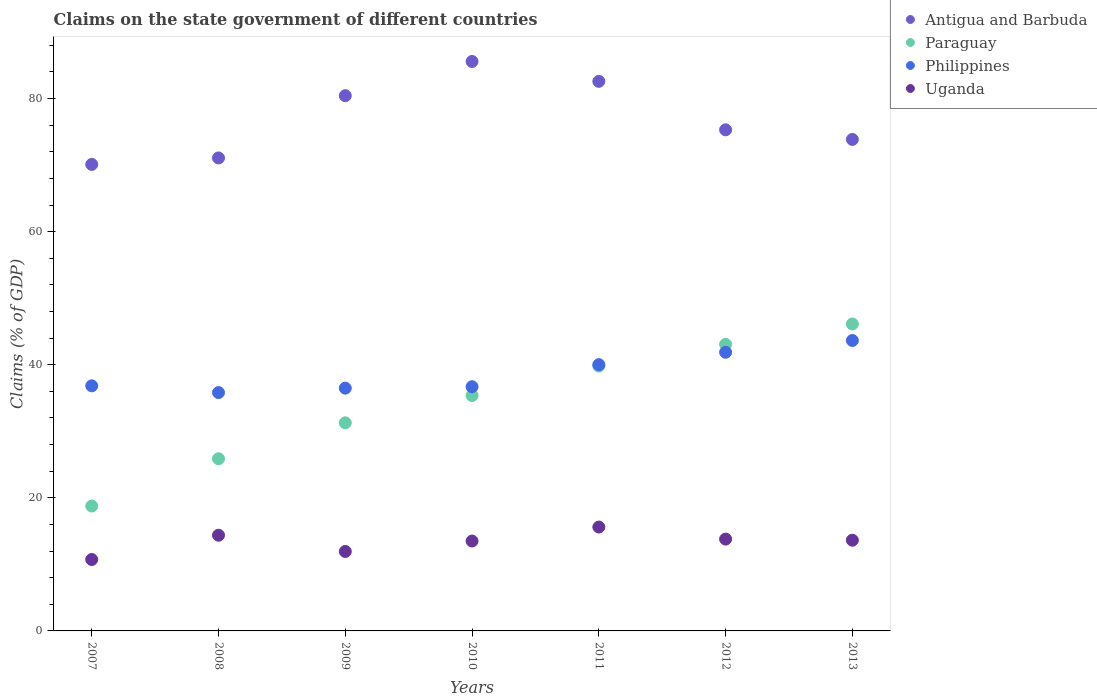What is the percentage of GDP claimed on the state government in Uganda in 2013?
Ensure brevity in your answer.  13.63. Across all years, what is the maximum percentage of GDP claimed on the state government in Uganda?
Make the answer very short. 15.61. Across all years, what is the minimum percentage of GDP claimed on the state government in Antigua and Barbuda?
Provide a succinct answer. 70.11. What is the total percentage of GDP claimed on the state government in Paraguay in the graph?
Make the answer very short. 240.28. What is the difference between the percentage of GDP claimed on the state government in Uganda in 2010 and that in 2013?
Keep it short and to the point. -0.12. What is the difference between the percentage of GDP claimed on the state government in Philippines in 2011 and the percentage of GDP claimed on the state government in Antigua and Barbuda in 2009?
Offer a very short reply. -40.42. What is the average percentage of GDP claimed on the state government in Philippines per year?
Make the answer very short. 38.77. In the year 2011, what is the difference between the percentage of GDP claimed on the state government in Antigua and Barbuda and percentage of GDP claimed on the state government in Philippines?
Your answer should be compact. 42.58. In how many years, is the percentage of GDP claimed on the state government in Uganda greater than 80 %?
Provide a short and direct response. 0. What is the ratio of the percentage of GDP claimed on the state government in Paraguay in 2007 to that in 2009?
Make the answer very short. 0.6. Is the percentage of GDP claimed on the state government in Paraguay in 2007 less than that in 2008?
Provide a succinct answer. Yes. What is the difference between the highest and the second highest percentage of GDP claimed on the state government in Antigua and Barbuda?
Keep it short and to the point. 2.99. What is the difference between the highest and the lowest percentage of GDP claimed on the state government in Uganda?
Offer a very short reply. 4.88. In how many years, is the percentage of GDP claimed on the state government in Philippines greater than the average percentage of GDP claimed on the state government in Philippines taken over all years?
Your response must be concise. 3. Is the sum of the percentage of GDP claimed on the state government in Paraguay in 2010 and 2012 greater than the maximum percentage of GDP claimed on the state government in Uganda across all years?
Ensure brevity in your answer.  Yes. Is it the case that in every year, the sum of the percentage of GDP claimed on the state government in Paraguay and percentage of GDP claimed on the state government in Philippines  is greater than the sum of percentage of GDP claimed on the state government in Antigua and Barbuda and percentage of GDP claimed on the state government in Uganda?
Your answer should be compact. No. Is it the case that in every year, the sum of the percentage of GDP claimed on the state government in Antigua and Barbuda and percentage of GDP claimed on the state government in Paraguay  is greater than the percentage of GDP claimed on the state government in Philippines?
Offer a very short reply. Yes. Does the percentage of GDP claimed on the state government in Paraguay monotonically increase over the years?
Offer a terse response. Yes. Is the percentage of GDP claimed on the state government in Uganda strictly less than the percentage of GDP claimed on the state government in Philippines over the years?
Your answer should be compact. Yes. How many dotlines are there?
Your answer should be compact. 4. How many years are there in the graph?
Provide a short and direct response. 7. What is the difference between two consecutive major ticks on the Y-axis?
Your response must be concise. 20. Are the values on the major ticks of Y-axis written in scientific E-notation?
Ensure brevity in your answer.  No. Does the graph contain grids?
Make the answer very short. No. Where does the legend appear in the graph?
Provide a short and direct response. Top right. How many legend labels are there?
Offer a terse response. 4. What is the title of the graph?
Keep it short and to the point. Claims on the state government of different countries. Does "Guatemala" appear as one of the legend labels in the graph?
Keep it short and to the point. No. What is the label or title of the Y-axis?
Make the answer very short. Claims (% of GDP). What is the Claims (% of GDP) in Antigua and Barbuda in 2007?
Your answer should be compact. 70.11. What is the Claims (% of GDP) in Paraguay in 2007?
Your answer should be very brief. 18.77. What is the Claims (% of GDP) of Philippines in 2007?
Provide a succinct answer. 36.83. What is the Claims (% of GDP) of Uganda in 2007?
Your response must be concise. 10.73. What is the Claims (% of GDP) of Antigua and Barbuda in 2008?
Provide a short and direct response. 71.08. What is the Claims (% of GDP) of Paraguay in 2008?
Offer a very short reply. 25.87. What is the Claims (% of GDP) of Philippines in 2008?
Give a very brief answer. 35.82. What is the Claims (% of GDP) of Uganda in 2008?
Provide a short and direct response. 14.38. What is the Claims (% of GDP) in Antigua and Barbuda in 2009?
Offer a terse response. 80.43. What is the Claims (% of GDP) of Paraguay in 2009?
Your response must be concise. 31.28. What is the Claims (% of GDP) of Philippines in 2009?
Your answer should be very brief. 36.48. What is the Claims (% of GDP) in Uganda in 2009?
Ensure brevity in your answer.  11.94. What is the Claims (% of GDP) of Antigua and Barbuda in 2010?
Provide a short and direct response. 85.58. What is the Claims (% of GDP) in Paraguay in 2010?
Your answer should be compact. 35.37. What is the Claims (% of GDP) in Philippines in 2010?
Provide a succinct answer. 36.7. What is the Claims (% of GDP) in Uganda in 2010?
Provide a succinct answer. 13.51. What is the Claims (% of GDP) in Antigua and Barbuda in 2011?
Your answer should be compact. 82.59. What is the Claims (% of GDP) of Paraguay in 2011?
Make the answer very short. 39.8. What is the Claims (% of GDP) of Philippines in 2011?
Offer a terse response. 40.02. What is the Claims (% of GDP) of Uganda in 2011?
Keep it short and to the point. 15.61. What is the Claims (% of GDP) of Antigua and Barbuda in 2012?
Give a very brief answer. 75.3. What is the Claims (% of GDP) of Paraguay in 2012?
Offer a very short reply. 43.07. What is the Claims (% of GDP) of Philippines in 2012?
Ensure brevity in your answer.  41.88. What is the Claims (% of GDP) in Uganda in 2012?
Offer a very short reply. 13.8. What is the Claims (% of GDP) of Antigua and Barbuda in 2013?
Keep it short and to the point. 73.86. What is the Claims (% of GDP) of Paraguay in 2013?
Keep it short and to the point. 46.13. What is the Claims (% of GDP) of Philippines in 2013?
Your answer should be very brief. 43.65. What is the Claims (% of GDP) in Uganda in 2013?
Make the answer very short. 13.63. Across all years, what is the maximum Claims (% of GDP) in Antigua and Barbuda?
Offer a terse response. 85.58. Across all years, what is the maximum Claims (% of GDP) of Paraguay?
Ensure brevity in your answer.  46.13. Across all years, what is the maximum Claims (% of GDP) in Philippines?
Keep it short and to the point. 43.65. Across all years, what is the maximum Claims (% of GDP) of Uganda?
Ensure brevity in your answer.  15.61. Across all years, what is the minimum Claims (% of GDP) of Antigua and Barbuda?
Give a very brief answer. 70.11. Across all years, what is the minimum Claims (% of GDP) of Paraguay?
Your answer should be very brief. 18.77. Across all years, what is the minimum Claims (% of GDP) of Philippines?
Offer a terse response. 35.82. Across all years, what is the minimum Claims (% of GDP) in Uganda?
Give a very brief answer. 10.73. What is the total Claims (% of GDP) in Antigua and Barbuda in the graph?
Ensure brevity in your answer.  538.95. What is the total Claims (% of GDP) of Paraguay in the graph?
Provide a short and direct response. 240.28. What is the total Claims (% of GDP) in Philippines in the graph?
Your answer should be very brief. 271.37. What is the total Claims (% of GDP) of Uganda in the graph?
Make the answer very short. 93.6. What is the difference between the Claims (% of GDP) of Antigua and Barbuda in 2007 and that in 2008?
Your response must be concise. -0.97. What is the difference between the Claims (% of GDP) of Paraguay in 2007 and that in 2008?
Make the answer very short. -7.1. What is the difference between the Claims (% of GDP) of Philippines in 2007 and that in 2008?
Provide a short and direct response. 1.01. What is the difference between the Claims (% of GDP) of Uganda in 2007 and that in 2008?
Your answer should be compact. -3.65. What is the difference between the Claims (% of GDP) of Antigua and Barbuda in 2007 and that in 2009?
Offer a very short reply. -10.33. What is the difference between the Claims (% of GDP) in Paraguay in 2007 and that in 2009?
Keep it short and to the point. -12.51. What is the difference between the Claims (% of GDP) of Philippines in 2007 and that in 2009?
Ensure brevity in your answer.  0.35. What is the difference between the Claims (% of GDP) in Uganda in 2007 and that in 2009?
Give a very brief answer. -1.21. What is the difference between the Claims (% of GDP) of Antigua and Barbuda in 2007 and that in 2010?
Ensure brevity in your answer.  -15.47. What is the difference between the Claims (% of GDP) in Paraguay in 2007 and that in 2010?
Offer a very short reply. -16.61. What is the difference between the Claims (% of GDP) of Philippines in 2007 and that in 2010?
Your answer should be very brief. 0.13. What is the difference between the Claims (% of GDP) of Uganda in 2007 and that in 2010?
Offer a terse response. -2.78. What is the difference between the Claims (% of GDP) in Antigua and Barbuda in 2007 and that in 2011?
Your answer should be very brief. -12.48. What is the difference between the Claims (% of GDP) in Paraguay in 2007 and that in 2011?
Offer a very short reply. -21.03. What is the difference between the Claims (% of GDP) in Philippines in 2007 and that in 2011?
Your response must be concise. -3.18. What is the difference between the Claims (% of GDP) in Uganda in 2007 and that in 2011?
Offer a terse response. -4.88. What is the difference between the Claims (% of GDP) in Antigua and Barbuda in 2007 and that in 2012?
Your answer should be compact. -5.2. What is the difference between the Claims (% of GDP) in Paraguay in 2007 and that in 2012?
Your answer should be very brief. -24.3. What is the difference between the Claims (% of GDP) of Philippines in 2007 and that in 2012?
Provide a short and direct response. -5.04. What is the difference between the Claims (% of GDP) of Uganda in 2007 and that in 2012?
Your answer should be compact. -3.07. What is the difference between the Claims (% of GDP) in Antigua and Barbuda in 2007 and that in 2013?
Provide a short and direct response. -3.75. What is the difference between the Claims (% of GDP) in Paraguay in 2007 and that in 2013?
Your response must be concise. -27.36. What is the difference between the Claims (% of GDP) in Philippines in 2007 and that in 2013?
Your answer should be very brief. -6.81. What is the difference between the Claims (% of GDP) in Uganda in 2007 and that in 2013?
Your answer should be very brief. -2.9. What is the difference between the Claims (% of GDP) in Antigua and Barbuda in 2008 and that in 2009?
Provide a short and direct response. -9.35. What is the difference between the Claims (% of GDP) in Paraguay in 2008 and that in 2009?
Offer a terse response. -5.4. What is the difference between the Claims (% of GDP) in Philippines in 2008 and that in 2009?
Make the answer very short. -0.66. What is the difference between the Claims (% of GDP) of Uganda in 2008 and that in 2009?
Your answer should be very brief. 2.44. What is the difference between the Claims (% of GDP) of Antigua and Barbuda in 2008 and that in 2010?
Offer a very short reply. -14.5. What is the difference between the Claims (% of GDP) of Paraguay in 2008 and that in 2010?
Keep it short and to the point. -9.5. What is the difference between the Claims (% of GDP) in Philippines in 2008 and that in 2010?
Provide a succinct answer. -0.88. What is the difference between the Claims (% of GDP) in Uganda in 2008 and that in 2010?
Provide a succinct answer. 0.87. What is the difference between the Claims (% of GDP) in Antigua and Barbuda in 2008 and that in 2011?
Ensure brevity in your answer.  -11.51. What is the difference between the Claims (% of GDP) of Paraguay in 2008 and that in 2011?
Offer a very short reply. -13.93. What is the difference between the Claims (% of GDP) of Philippines in 2008 and that in 2011?
Make the answer very short. -4.2. What is the difference between the Claims (% of GDP) of Uganda in 2008 and that in 2011?
Your response must be concise. -1.23. What is the difference between the Claims (% of GDP) in Antigua and Barbuda in 2008 and that in 2012?
Give a very brief answer. -4.23. What is the difference between the Claims (% of GDP) of Paraguay in 2008 and that in 2012?
Keep it short and to the point. -17.2. What is the difference between the Claims (% of GDP) of Philippines in 2008 and that in 2012?
Make the answer very short. -6.06. What is the difference between the Claims (% of GDP) of Uganda in 2008 and that in 2012?
Offer a very short reply. 0.58. What is the difference between the Claims (% of GDP) of Antigua and Barbuda in 2008 and that in 2013?
Ensure brevity in your answer.  -2.78. What is the difference between the Claims (% of GDP) of Paraguay in 2008 and that in 2013?
Keep it short and to the point. -20.26. What is the difference between the Claims (% of GDP) of Philippines in 2008 and that in 2013?
Your answer should be very brief. -7.83. What is the difference between the Claims (% of GDP) of Uganda in 2008 and that in 2013?
Keep it short and to the point. 0.75. What is the difference between the Claims (% of GDP) in Antigua and Barbuda in 2009 and that in 2010?
Your answer should be compact. -5.14. What is the difference between the Claims (% of GDP) in Paraguay in 2009 and that in 2010?
Give a very brief answer. -4.1. What is the difference between the Claims (% of GDP) in Philippines in 2009 and that in 2010?
Offer a very short reply. -0.22. What is the difference between the Claims (% of GDP) in Uganda in 2009 and that in 2010?
Provide a short and direct response. -1.57. What is the difference between the Claims (% of GDP) in Antigua and Barbuda in 2009 and that in 2011?
Make the answer very short. -2.16. What is the difference between the Claims (% of GDP) in Paraguay in 2009 and that in 2011?
Your answer should be very brief. -8.52. What is the difference between the Claims (% of GDP) in Philippines in 2009 and that in 2011?
Give a very brief answer. -3.53. What is the difference between the Claims (% of GDP) of Uganda in 2009 and that in 2011?
Give a very brief answer. -3.67. What is the difference between the Claims (% of GDP) in Antigua and Barbuda in 2009 and that in 2012?
Your response must be concise. 5.13. What is the difference between the Claims (% of GDP) in Paraguay in 2009 and that in 2012?
Provide a short and direct response. -11.79. What is the difference between the Claims (% of GDP) in Philippines in 2009 and that in 2012?
Give a very brief answer. -5.39. What is the difference between the Claims (% of GDP) in Uganda in 2009 and that in 2012?
Provide a succinct answer. -1.86. What is the difference between the Claims (% of GDP) of Antigua and Barbuda in 2009 and that in 2013?
Provide a succinct answer. 6.57. What is the difference between the Claims (% of GDP) of Paraguay in 2009 and that in 2013?
Give a very brief answer. -14.85. What is the difference between the Claims (% of GDP) in Philippines in 2009 and that in 2013?
Provide a succinct answer. -7.16. What is the difference between the Claims (% of GDP) of Uganda in 2009 and that in 2013?
Your answer should be very brief. -1.69. What is the difference between the Claims (% of GDP) in Antigua and Barbuda in 2010 and that in 2011?
Offer a very short reply. 2.99. What is the difference between the Claims (% of GDP) in Paraguay in 2010 and that in 2011?
Keep it short and to the point. -4.42. What is the difference between the Claims (% of GDP) of Philippines in 2010 and that in 2011?
Ensure brevity in your answer.  -3.32. What is the difference between the Claims (% of GDP) of Uganda in 2010 and that in 2011?
Keep it short and to the point. -2.1. What is the difference between the Claims (% of GDP) of Antigua and Barbuda in 2010 and that in 2012?
Keep it short and to the point. 10.27. What is the difference between the Claims (% of GDP) of Paraguay in 2010 and that in 2012?
Give a very brief answer. -7.69. What is the difference between the Claims (% of GDP) of Philippines in 2010 and that in 2012?
Provide a short and direct response. -5.18. What is the difference between the Claims (% of GDP) in Uganda in 2010 and that in 2012?
Keep it short and to the point. -0.29. What is the difference between the Claims (% of GDP) of Antigua and Barbuda in 2010 and that in 2013?
Provide a short and direct response. 11.71. What is the difference between the Claims (% of GDP) in Paraguay in 2010 and that in 2013?
Give a very brief answer. -10.75. What is the difference between the Claims (% of GDP) in Philippines in 2010 and that in 2013?
Your answer should be compact. -6.95. What is the difference between the Claims (% of GDP) of Uganda in 2010 and that in 2013?
Give a very brief answer. -0.12. What is the difference between the Claims (% of GDP) of Antigua and Barbuda in 2011 and that in 2012?
Your answer should be very brief. 7.29. What is the difference between the Claims (% of GDP) in Paraguay in 2011 and that in 2012?
Your answer should be compact. -3.27. What is the difference between the Claims (% of GDP) in Philippines in 2011 and that in 2012?
Ensure brevity in your answer.  -1.86. What is the difference between the Claims (% of GDP) in Uganda in 2011 and that in 2012?
Keep it short and to the point. 1.81. What is the difference between the Claims (% of GDP) of Antigua and Barbuda in 2011 and that in 2013?
Make the answer very short. 8.73. What is the difference between the Claims (% of GDP) of Paraguay in 2011 and that in 2013?
Make the answer very short. -6.33. What is the difference between the Claims (% of GDP) in Philippines in 2011 and that in 2013?
Offer a very short reply. -3.63. What is the difference between the Claims (% of GDP) in Uganda in 2011 and that in 2013?
Offer a very short reply. 1.98. What is the difference between the Claims (% of GDP) in Antigua and Barbuda in 2012 and that in 2013?
Ensure brevity in your answer.  1.44. What is the difference between the Claims (% of GDP) in Paraguay in 2012 and that in 2013?
Your answer should be compact. -3.06. What is the difference between the Claims (% of GDP) of Philippines in 2012 and that in 2013?
Offer a terse response. -1.77. What is the difference between the Claims (% of GDP) in Uganda in 2012 and that in 2013?
Your answer should be very brief. 0.17. What is the difference between the Claims (% of GDP) in Antigua and Barbuda in 2007 and the Claims (% of GDP) in Paraguay in 2008?
Offer a terse response. 44.24. What is the difference between the Claims (% of GDP) of Antigua and Barbuda in 2007 and the Claims (% of GDP) of Philippines in 2008?
Provide a short and direct response. 34.29. What is the difference between the Claims (% of GDP) in Antigua and Barbuda in 2007 and the Claims (% of GDP) in Uganda in 2008?
Make the answer very short. 55.73. What is the difference between the Claims (% of GDP) in Paraguay in 2007 and the Claims (% of GDP) in Philippines in 2008?
Give a very brief answer. -17.05. What is the difference between the Claims (% of GDP) in Paraguay in 2007 and the Claims (% of GDP) in Uganda in 2008?
Offer a terse response. 4.39. What is the difference between the Claims (% of GDP) in Philippines in 2007 and the Claims (% of GDP) in Uganda in 2008?
Provide a succinct answer. 22.45. What is the difference between the Claims (% of GDP) in Antigua and Barbuda in 2007 and the Claims (% of GDP) in Paraguay in 2009?
Offer a very short reply. 38.83. What is the difference between the Claims (% of GDP) in Antigua and Barbuda in 2007 and the Claims (% of GDP) in Philippines in 2009?
Offer a very short reply. 33.62. What is the difference between the Claims (% of GDP) of Antigua and Barbuda in 2007 and the Claims (% of GDP) of Uganda in 2009?
Ensure brevity in your answer.  58.17. What is the difference between the Claims (% of GDP) in Paraguay in 2007 and the Claims (% of GDP) in Philippines in 2009?
Offer a terse response. -17.72. What is the difference between the Claims (% of GDP) of Paraguay in 2007 and the Claims (% of GDP) of Uganda in 2009?
Offer a very short reply. 6.83. What is the difference between the Claims (% of GDP) of Philippines in 2007 and the Claims (% of GDP) of Uganda in 2009?
Offer a very short reply. 24.89. What is the difference between the Claims (% of GDP) of Antigua and Barbuda in 2007 and the Claims (% of GDP) of Paraguay in 2010?
Offer a very short reply. 34.73. What is the difference between the Claims (% of GDP) of Antigua and Barbuda in 2007 and the Claims (% of GDP) of Philippines in 2010?
Your answer should be very brief. 33.41. What is the difference between the Claims (% of GDP) in Antigua and Barbuda in 2007 and the Claims (% of GDP) in Uganda in 2010?
Keep it short and to the point. 56.6. What is the difference between the Claims (% of GDP) of Paraguay in 2007 and the Claims (% of GDP) of Philippines in 2010?
Offer a very short reply. -17.93. What is the difference between the Claims (% of GDP) of Paraguay in 2007 and the Claims (% of GDP) of Uganda in 2010?
Make the answer very short. 5.26. What is the difference between the Claims (% of GDP) of Philippines in 2007 and the Claims (% of GDP) of Uganda in 2010?
Provide a succinct answer. 23.32. What is the difference between the Claims (% of GDP) of Antigua and Barbuda in 2007 and the Claims (% of GDP) of Paraguay in 2011?
Offer a terse response. 30.31. What is the difference between the Claims (% of GDP) in Antigua and Barbuda in 2007 and the Claims (% of GDP) in Philippines in 2011?
Your response must be concise. 30.09. What is the difference between the Claims (% of GDP) in Antigua and Barbuda in 2007 and the Claims (% of GDP) in Uganda in 2011?
Keep it short and to the point. 54.5. What is the difference between the Claims (% of GDP) of Paraguay in 2007 and the Claims (% of GDP) of Philippines in 2011?
Give a very brief answer. -21.25. What is the difference between the Claims (% of GDP) of Paraguay in 2007 and the Claims (% of GDP) of Uganda in 2011?
Make the answer very short. 3.16. What is the difference between the Claims (% of GDP) in Philippines in 2007 and the Claims (% of GDP) in Uganda in 2011?
Offer a terse response. 21.22. What is the difference between the Claims (% of GDP) of Antigua and Barbuda in 2007 and the Claims (% of GDP) of Paraguay in 2012?
Your answer should be compact. 27.04. What is the difference between the Claims (% of GDP) in Antigua and Barbuda in 2007 and the Claims (% of GDP) in Philippines in 2012?
Provide a short and direct response. 28.23. What is the difference between the Claims (% of GDP) of Antigua and Barbuda in 2007 and the Claims (% of GDP) of Uganda in 2012?
Your response must be concise. 56.31. What is the difference between the Claims (% of GDP) of Paraguay in 2007 and the Claims (% of GDP) of Philippines in 2012?
Provide a short and direct response. -23.11. What is the difference between the Claims (% of GDP) in Paraguay in 2007 and the Claims (% of GDP) in Uganda in 2012?
Provide a short and direct response. 4.97. What is the difference between the Claims (% of GDP) of Philippines in 2007 and the Claims (% of GDP) of Uganda in 2012?
Your response must be concise. 23.03. What is the difference between the Claims (% of GDP) in Antigua and Barbuda in 2007 and the Claims (% of GDP) in Paraguay in 2013?
Your answer should be very brief. 23.98. What is the difference between the Claims (% of GDP) in Antigua and Barbuda in 2007 and the Claims (% of GDP) in Philippines in 2013?
Provide a short and direct response. 26.46. What is the difference between the Claims (% of GDP) in Antigua and Barbuda in 2007 and the Claims (% of GDP) in Uganda in 2013?
Make the answer very short. 56.47. What is the difference between the Claims (% of GDP) in Paraguay in 2007 and the Claims (% of GDP) in Philippines in 2013?
Make the answer very short. -24.88. What is the difference between the Claims (% of GDP) in Paraguay in 2007 and the Claims (% of GDP) in Uganda in 2013?
Keep it short and to the point. 5.14. What is the difference between the Claims (% of GDP) in Philippines in 2007 and the Claims (% of GDP) in Uganda in 2013?
Your answer should be very brief. 23.2. What is the difference between the Claims (% of GDP) in Antigua and Barbuda in 2008 and the Claims (% of GDP) in Paraguay in 2009?
Offer a terse response. 39.8. What is the difference between the Claims (% of GDP) in Antigua and Barbuda in 2008 and the Claims (% of GDP) in Philippines in 2009?
Provide a short and direct response. 34.6. What is the difference between the Claims (% of GDP) of Antigua and Barbuda in 2008 and the Claims (% of GDP) of Uganda in 2009?
Your answer should be very brief. 59.14. What is the difference between the Claims (% of GDP) in Paraguay in 2008 and the Claims (% of GDP) in Philippines in 2009?
Your response must be concise. -10.61. What is the difference between the Claims (% of GDP) in Paraguay in 2008 and the Claims (% of GDP) in Uganda in 2009?
Ensure brevity in your answer.  13.93. What is the difference between the Claims (% of GDP) of Philippines in 2008 and the Claims (% of GDP) of Uganda in 2009?
Your response must be concise. 23.88. What is the difference between the Claims (% of GDP) in Antigua and Barbuda in 2008 and the Claims (% of GDP) in Paraguay in 2010?
Give a very brief answer. 35.7. What is the difference between the Claims (% of GDP) in Antigua and Barbuda in 2008 and the Claims (% of GDP) in Philippines in 2010?
Your answer should be compact. 34.38. What is the difference between the Claims (% of GDP) of Antigua and Barbuda in 2008 and the Claims (% of GDP) of Uganda in 2010?
Offer a terse response. 57.57. What is the difference between the Claims (% of GDP) in Paraguay in 2008 and the Claims (% of GDP) in Philippines in 2010?
Your answer should be compact. -10.83. What is the difference between the Claims (% of GDP) of Paraguay in 2008 and the Claims (% of GDP) of Uganda in 2010?
Your answer should be very brief. 12.36. What is the difference between the Claims (% of GDP) in Philippines in 2008 and the Claims (% of GDP) in Uganda in 2010?
Provide a short and direct response. 22.31. What is the difference between the Claims (% of GDP) in Antigua and Barbuda in 2008 and the Claims (% of GDP) in Paraguay in 2011?
Give a very brief answer. 31.28. What is the difference between the Claims (% of GDP) in Antigua and Barbuda in 2008 and the Claims (% of GDP) in Philippines in 2011?
Give a very brief answer. 31.06. What is the difference between the Claims (% of GDP) in Antigua and Barbuda in 2008 and the Claims (% of GDP) in Uganda in 2011?
Make the answer very short. 55.47. What is the difference between the Claims (% of GDP) of Paraguay in 2008 and the Claims (% of GDP) of Philippines in 2011?
Make the answer very short. -14.14. What is the difference between the Claims (% of GDP) of Paraguay in 2008 and the Claims (% of GDP) of Uganda in 2011?
Provide a short and direct response. 10.26. What is the difference between the Claims (% of GDP) of Philippines in 2008 and the Claims (% of GDP) of Uganda in 2011?
Keep it short and to the point. 20.21. What is the difference between the Claims (% of GDP) of Antigua and Barbuda in 2008 and the Claims (% of GDP) of Paraguay in 2012?
Your answer should be compact. 28.01. What is the difference between the Claims (% of GDP) of Antigua and Barbuda in 2008 and the Claims (% of GDP) of Philippines in 2012?
Ensure brevity in your answer.  29.2. What is the difference between the Claims (% of GDP) of Antigua and Barbuda in 2008 and the Claims (% of GDP) of Uganda in 2012?
Your answer should be very brief. 57.28. What is the difference between the Claims (% of GDP) of Paraguay in 2008 and the Claims (% of GDP) of Philippines in 2012?
Your response must be concise. -16. What is the difference between the Claims (% of GDP) in Paraguay in 2008 and the Claims (% of GDP) in Uganda in 2012?
Provide a short and direct response. 12.07. What is the difference between the Claims (% of GDP) in Philippines in 2008 and the Claims (% of GDP) in Uganda in 2012?
Make the answer very short. 22.02. What is the difference between the Claims (% of GDP) of Antigua and Barbuda in 2008 and the Claims (% of GDP) of Paraguay in 2013?
Your response must be concise. 24.95. What is the difference between the Claims (% of GDP) in Antigua and Barbuda in 2008 and the Claims (% of GDP) in Philippines in 2013?
Provide a succinct answer. 27.43. What is the difference between the Claims (% of GDP) in Antigua and Barbuda in 2008 and the Claims (% of GDP) in Uganda in 2013?
Your response must be concise. 57.45. What is the difference between the Claims (% of GDP) in Paraguay in 2008 and the Claims (% of GDP) in Philippines in 2013?
Provide a succinct answer. -17.77. What is the difference between the Claims (% of GDP) of Paraguay in 2008 and the Claims (% of GDP) of Uganda in 2013?
Keep it short and to the point. 12.24. What is the difference between the Claims (% of GDP) in Philippines in 2008 and the Claims (% of GDP) in Uganda in 2013?
Your answer should be compact. 22.19. What is the difference between the Claims (% of GDP) in Antigua and Barbuda in 2009 and the Claims (% of GDP) in Paraguay in 2010?
Your answer should be compact. 45.06. What is the difference between the Claims (% of GDP) of Antigua and Barbuda in 2009 and the Claims (% of GDP) of Philippines in 2010?
Provide a succinct answer. 43.74. What is the difference between the Claims (% of GDP) in Antigua and Barbuda in 2009 and the Claims (% of GDP) in Uganda in 2010?
Your answer should be compact. 66.92. What is the difference between the Claims (% of GDP) of Paraguay in 2009 and the Claims (% of GDP) of Philippines in 2010?
Your answer should be compact. -5.42. What is the difference between the Claims (% of GDP) in Paraguay in 2009 and the Claims (% of GDP) in Uganda in 2010?
Your answer should be compact. 17.77. What is the difference between the Claims (% of GDP) of Philippines in 2009 and the Claims (% of GDP) of Uganda in 2010?
Ensure brevity in your answer.  22.97. What is the difference between the Claims (% of GDP) of Antigua and Barbuda in 2009 and the Claims (% of GDP) of Paraguay in 2011?
Make the answer very short. 40.64. What is the difference between the Claims (% of GDP) in Antigua and Barbuda in 2009 and the Claims (% of GDP) in Philippines in 2011?
Offer a very short reply. 40.42. What is the difference between the Claims (% of GDP) of Antigua and Barbuda in 2009 and the Claims (% of GDP) of Uganda in 2011?
Make the answer very short. 64.82. What is the difference between the Claims (% of GDP) of Paraguay in 2009 and the Claims (% of GDP) of Philippines in 2011?
Give a very brief answer. -8.74. What is the difference between the Claims (% of GDP) in Paraguay in 2009 and the Claims (% of GDP) in Uganda in 2011?
Make the answer very short. 15.66. What is the difference between the Claims (% of GDP) of Philippines in 2009 and the Claims (% of GDP) of Uganda in 2011?
Provide a short and direct response. 20.87. What is the difference between the Claims (% of GDP) in Antigua and Barbuda in 2009 and the Claims (% of GDP) in Paraguay in 2012?
Offer a terse response. 37.37. What is the difference between the Claims (% of GDP) of Antigua and Barbuda in 2009 and the Claims (% of GDP) of Philippines in 2012?
Your response must be concise. 38.56. What is the difference between the Claims (% of GDP) in Antigua and Barbuda in 2009 and the Claims (% of GDP) in Uganda in 2012?
Your response must be concise. 66.64. What is the difference between the Claims (% of GDP) of Paraguay in 2009 and the Claims (% of GDP) of Philippines in 2012?
Your answer should be compact. -10.6. What is the difference between the Claims (% of GDP) in Paraguay in 2009 and the Claims (% of GDP) in Uganda in 2012?
Give a very brief answer. 17.48. What is the difference between the Claims (% of GDP) of Philippines in 2009 and the Claims (% of GDP) of Uganda in 2012?
Your answer should be very brief. 22.68. What is the difference between the Claims (% of GDP) of Antigua and Barbuda in 2009 and the Claims (% of GDP) of Paraguay in 2013?
Make the answer very short. 34.31. What is the difference between the Claims (% of GDP) in Antigua and Barbuda in 2009 and the Claims (% of GDP) in Philippines in 2013?
Provide a short and direct response. 36.79. What is the difference between the Claims (% of GDP) of Antigua and Barbuda in 2009 and the Claims (% of GDP) of Uganda in 2013?
Ensure brevity in your answer.  66.8. What is the difference between the Claims (% of GDP) of Paraguay in 2009 and the Claims (% of GDP) of Philippines in 2013?
Your answer should be very brief. -12.37. What is the difference between the Claims (% of GDP) of Paraguay in 2009 and the Claims (% of GDP) of Uganda in 2013?
Keep it short and to the point. 17.64. What is the difference between the Claims (% of GDP) in Philippines in 2009 and the Claims (% of GDP) in Uganda in 2013?
Offer a terse response. 22.85. What is the difference between the Claims (% of GDP) of Antigua and Barbuda in 2010 and the Claims (% of GDP) of Paraguay in 2011?
Keep it short and to the point. 45.78. What is the difference between the Claims (% of GDP) of Antigua and Barbuda in 2010 and the Claims (% of GDP) of Philippines in 2011?
Provide a succinct answer. 45.56. What is the difference between the Claims (% of GDP) of Antigua and Barbuda in 2010 and the Claims (% of GDP) of Uganda in 2011?
Provide a succinct answer. 69.97. What is the difference between the Claims (% of GDP) in Paraguay in 2010 and the Claims (% of GDP) in Philippines in 2011?
Keep it short and to the point. -4.64. What is the difference between the Claims (% of GDP) of Paraguay in 2010 and the Claims (% of GDP) of Uganda in 2011?
Your response must be concise. 19.76. What is the difference between the Claims (% of GDP) in Philippines in 2010 and the Claims (% of GDP) in Uganda in 2011?
Provide a short and direct response. 21.09. What is the difference between the Claims (% of GDP) in Antigua and Barbuda in 2010 and the Claims (% of GDP) in Paraguay in 2012?
Offer a very short reply. 42.51. What is the difference between the Claims (% of GDP) in Antigua and Barbuda in 2010 and the Claims (% of GDP) in Philippines in 2012?
Your response must be concise. 43.7. What is the difference between the Claims (% of GDP) in Antigua and Barbuda in 2010 and the Claims (% of GDP) in Uganda in 2012?
Ensure brevity in your answer.  71.78. What is the difference between the Claims (% of GDP) in Paraguay in 2010 and the Claims (% of GDP) in Philippines in 2012?
Give a very brief answer. -6.5. What is the difference between the Claims (% of GDP) of Paraguay in 2010 and the Claims (% of GDP) of Uganda in 2012?
Your answer should be very brief. 21.58. What is the difference between the Claims (% of GDP) of Philippines in 2010 and the Claims (% of GDP) of Uganda in 2012?
Your answer should be compact. 22.9. What is the difference between the Claims (% of GDP) in Antigua and Barbuda in 2010 and the Claims (% of GDP) in Paraguay in 2013?
Ensure brevity in your answer.  39.45. What is the difference between the Claims (% of GDP) in Antigua and Barbuda in 2010 and the Claims (% of GDP) in Philippines in 2013?
Offer a very short reply. 41.93. What is the difference between the Claims (% of GDP) in Antigua and Barbuda in 2010 and the Claims (% of GDP) in Uganda in 2013?
Ensure brevity in your answer.  71.94. What is the difference between the Claims (% of GDP) in Paraguay in 2010 and the Claims (% of GDP) in Philippines in 2013?
Offer a terse response. -8.27. What is the difference between the Claims (% of GDP) in Paraguay in 2010 and the Claims (% of GDP) in Uganda in 2013?
Ensure brevity in your answer.  21.74. What is the difference between the Claims (% of GDP) of Philippines in 2010 and the Claims (% of GDP) of Uganda in 2013?
Your response must be concise. 23.07. What is the difference between the Claims (% of GDP) of Antigua and Barbuda in 2011 and the Claims (% of GDP) of Paraguay in 2012?
Ensure brevity in your answer.  39.52. What is the difference between the Claims (% of GDP) of Antigua and Barbuda in 2011 and the Claims (% of GDP) of Philippines in 2012?
Offer a terse response. 40.72. What is the difference between the Claims (% of GDP) of Antigua and Barbuda in 2011 and the Claims (% of GDP) of Uganda in 2012?
Offer a terse response. 68.79. What is the difference between the Claims (% of GDP) of Paraguay in 2011 and the Claims (% of GDP) of Philippines in 2012?
Ensure brevity in your answer.  -2.08. What is the difference between the Claims (% of GDP) in Paraguay in 2011 and the Claims (% of GDP) in Uganda in 2012?
Ensure brevity in your answer.  26. What is the difference between the Claims (% of GDP) in Philippines in 2011 and the Claims (% of GDP) in Uganda in 2012?
Keep it short and to the point. 26.22. What is the difference between the Claims (% of GDP) of Antigua and Barbuda in 2011 and the Claims (% of GDP) of Paraguay in 2013?
Make the answer very short. 36.46. What is the difference between the Claims (% of GDP) of Antigua and Barbuda in 2011 and the Claims (% of GDP) of Philippines in 2013?
Your answer should be compact. 38.94. What is the difference between the Claims (% of GDP) of Antigua and Barbuda in 2011 and the Claims (% of GDP) of Uganda in 2013?
Ensure brevity in your answer.  68.96. What is the difference between the Claims (% of GDP) of Paraguay in 2011 and the Claims (% of GDP) of Philippines in 2013?
Give a very brief answer. -3.85. What is the difference between the Claims (% of GDP) in Paraguay in 2011 and the Claims (% of GDP) in Uganda in 2013?
Offer a very short reply. 26.16. What is the difference between the Claims (% of GDP) of Philippines in 2011 and the Claims (% of GDP) of Uganda in 2013?
Offer a terse response. 26.38. What is the difference between the Claims (% of GDP) in Antigua and Barbuda in 2012 and the Claims (% of GDP) in Paraguay in 2013?
Give a very brief answer. 29.18. What is the difference between the Claims (% of GDP) in Antigua and Barbuda in 2012 and the Claims (% of GDP) in Philippines in 2013?
Keep it short and to the point. 31.66. What is the difference between the Claims (% of GDP) of Antigua and Barbuda in 2012 and the Claims (% of GDP) of Uganda in 2013?
Provide a short and direct response. 61.67. What is the difference between the Claims (% of GDP) of Paraguay in 2012 and the Claims (% of GDP) of Philippines in 2013?
Provide a succinct answer. -0.58. What is the difference between the Claims (% of GDP) in Paraguay in 2012 and the Claims (% of GDP) in Uganda in 2013?
Your answer should be very brief. 29.44. What is the difference between the Claims (% of GDP) in Philippines in 2012 and the Claims (% of GDP) in Uganda in 2013?
Your response must be concise. 28.24. What is the average Claims (% of GDP) in Antigua and Barbuda per year?
Offer a terse response. 76.99. What is the average Claims (% of GDP) in Paraguay per year?
Offer a very short reply. 34.33. What is the average Claims (% of GDP) of Philippines per year?
Provide a short and direct response. 38.77. What is the average Claims (% of GDP) of Uganda per year?
Your answer should be compact. 13.37. In the year 2007, what is the difference between the Claims (% of GDP) of Antigua and Barbuda and Claims (% of GDP) of Paraguay?
Give a very brief answer. 51.34. In the year 2007, what is the difference between the Claims (% of GDP) of Antigua and Barbuda and Claims (% of GDP) of Philippines?
Your answer should be compact. 33.27. In the year 2007, what is the difference between the Claims (% of GDP) in Antigua and Barbuda and Claims (% of GDP) in Uganda?
Offer a very short reply. 59.38. In the year 2007, what is the difference between the Claims (% of GDP) of Paraguay and Claims (% of GDP) of Philippines?
Provide a short and direct response. -18.07. In the year 2007, what is the difference between the Claims (% of GDP) of Paraguay and Claims (% of GDP) of Uganda?
Your answer should be very brief. 8.04. In the year 2007, what is the difference between the Claims (% of GDP) in Philippines and Claims (% of GDP) in Uganda?
Provide a succinct answer. 26.1. In the year 2008, what is the difference between the Claims (% of GDP) in Antigua and Barbuda and Claims (% of GDP) in Paraguay?
Keep it short and to the point. 45.21. In the year 2008, what is the difference between the Claims (% of GDP) in Antigua and Barbuda and Claims (% of GDP) in Philippines?
Give a very brief answer. 35.26. In the year 2008, what is the difference between the Claims (% of GDP) of Antigua and Barbuda and Claims (% of GDP) of Uganda?
Your response must be concise. 56.7. In the year 2008, what is the difference between the Claims (% of GDP) of Paraguay and Claims (% of GDP) of Philippines?
Offer a terse response. -9.95. In the year 2008, what is the difference between the Claims (% of GDP) in Paraguay and Claims (% of GDP) in Uganda?
Your answer should be very brief. 11.49. In the year 2008, what is the difference between the Claims (% of GDP) of Philippines and Claims (% of GDP) of Uganda?
Your answer should be compact. 21.44. In the year 2009, what is the difference between the Claims (% of GDP) in Antigua and Barbuda and Claims (% of GDP) in Paraguay?
Offer a very short reply. 49.16. In the year 2009, what is the difference between the Claims (% of GDP) in Antigua and Barbuda and Claims (% of GDP) in Philippines?
Your answer should be compact. 43.95. In the year 2009, what is the difference between the Claims (% of GDP) of Antigua and Barbuda and Claims (% of GDP) of Uganda?
Provide a short and direct response. 68.5. In the year 2009, what is the difference between the Claims (% of GDP) in Paraguay and Claims (% of GDP) in Philippines?
Your answer should be very brief. -5.21. In the year 2009, what is the difference between the Claims (% of GDP) of Paraguay and Claims (% of GDP) of Uganda?
Your answer should be very brief. 19.34. In the year 2009, what is the difference between the Claims (% of GDP) in Philippines and Claims (% of GDP) in Uganda?
Keep it short and to the point. 24.55. In the year 2010, what is the difference between the Claims (% of GDP) of Antigua and Barbuda and Claims (% of GDP) of Paraguay?
Provide a succinct answer. 50.2. In the year 2010, what is the difference between the Claims (% of GDP) in Antigua and Barbuda and Claims (% of GDP) in Philippines?
Your answer should be very brief. 48.88. In the year 2010, what is the difference between the Claims (% of GDP) of Antigua and Barbuda and Claims (% of GDP) of Uganda?
Ensure brevity in your answer.  72.07. In the year 2010, what is the difference between the Claims (% of GDP) in Paraguay and Claims (% of GDP) in Philippines?
Offer a terse response. -1.32. In the year 2010, what is the difference between the Claims (% of GDP) of Paraguay and Claims (% of GDP) of Uganda?
Provide a short and direct response. 21.87. In the year 2010, what is the difference between the Claims (% of GDP) in Philippines and Claims (% of GDP) in Uganda?
Ensure brevity in your answer.  23.19. In the year 2011, what is the difference between the Claims (% of GDP) in Antigua and Barbuda and Claims (% of GDP) in Paraguay?
Make the answer very short. 42.79. In the year 2011, what is the difference between the Claims (% of GDP) of Antigua and Barbuda and Claims (% of GDP) of Philippines?
Offer a terse response. 42.58. In the year 2011, what is the difference between the Claims (% of GDP) of Antigua and Barbuda and Claims (% of GDP) of Uganda?
Provide a short and direct response. 66.98. In the year 2011, what is the difference between the Claims (% of GDP) in Paraguay and Claims (% of GDP) in Philippines?
Offer a terse response. -0.22. In the year 2011, what is the difference between the Claims (% of GDP) of Paraguay and Claims (% of GDP) of Uganda?
Offer a very short reply. 24.19. In the year 2011, what is the difference between the Claims (% of GDP) in Philippines and Claims (% of GDP) in Uganda?
Keep it short and to the point. 24.4. In the year 2012, what is the difference between the Claims (% of GDP) in Antigua and Barbuda and Claims (% of GDP) in Paraguay?
Offer a terse response. 32.24. In the year 2012, what is the difference between the Claims (% of GDP) of Antigua and Barbuda and Claims (% of GDP) of Philippines?
Offer a very short reply. 33.43. In the year 2012, what is the difference between the Claims (% of GDP) of Antigua and Barbuda and Claims (% of GDP) of Uganda?
Provide a short and direct response. 61.51. In the year 2012, what is the difference between the Claims (% of GDP) in Paraguay and Claims (% of GDP) in Philippines?
Keep it short and to the point. 1.19. In the year 2012, what is the difference between the Claims (% of GDP) of Paraguay and Claims (% of GDP) of Uganda?
Ensure brevity in your answer.  29.27. In the year 2012, what is the difference between the Claims (% of GDP) in Philippines and Claims (% of GDP) in Uganda?
Ensure brevity in your answer.  28.08. In the year 2013, what is the difference between the Claims (% of GDP) of Antigua and Barbuda and Claims (% of GDP) of Paraguay?
Make the answer very short. 27.73. In the year 2013, what is the difference between the Claims (% of GDP) of Antigua and Barbuda and Claims (% of GDP) of Philippines?
Offer a terse response. 30.21. In the year 2013, what is the difference between the Claims (% of GDP) in Antigua and Barbuda and Claims (% of GDP) in Uganda?
Your answer should be compact. 60.23. In the year 2013, what is the difference between the Claims (% of GDP) of Paraguay and Claims (% of GDP) of Philippines?
Make the answer very short. 2.48. In the year 2013, what is the difference between the Claims (% of GDP) in Paraguay and Claims (% of GDP) in Uganda?
Provide a succinct answer. 32.49. In the year 2013, what is the difference between the Claims (% of GDP) in Philippines and Claims (% of GDP) in Uganda?
Make the answer very short. 30.01. What is the ratio of the Claims (% of GDP) in Antigua and Barbuda in 2007 to that in 2008?
Your answer should be very brief. 0.99. What is the ratio of the Claims (% of GDP) in Paraguay in 2007 to that in 2008?
Your response must be concise. 0.73. What is the ratio of the Claims (% of GDP) of Philippines in 2007 to that in 2008?
Give a very brief answer. 1.03. What is the ratio of the Claims (% of GDP) in Uganda in 2007 to that in 2008?
Provide a short and direct response. 0.75. What is the ratio of the Claims (% of GDP) of Antigua and Barbuda in 2007 to that in 2009?
Your answer should be compact. 0.87. What is the ratio of the Claims (% of GDP) in Paraguay in 2007 to that in 2009?
Offer a very short reply. 0.6. What is the ratio of the Claims (% of GDP) of Philippines in 2007 to that in 2009?
Provide a succinct answer. 1.01. What is the ratio of the Claims (% of GDP) of Uganda in 2007 to that in 2009?
Ensure brevity in your answer.  0.9. What is the ratio of the Claims (% of GDP) in Antigua and Barbuda in 2007 to that in 2010?
Keep it short and to the point. 0.82. What is the ratio of the Claims (% of GDP) in Paraguay in 2007 to that in 2010?
Give a very brief answer. 0.53. What is the ratio of the Claims (% of GDP) of Philippines in 2007 to that in 2010?
Keep it short and to the point. 1. What is the ratio of the Claims (% of GDP) in Uganda in 2007 to that in 2010?
Make the answer very short. 0.79. What is the ratio of the Claims (% of GDP) in Antigua and Barbuda in 2007 to that in 2011?
Make the answer very short. 0.85. What is the ratio of the Claims (% of GDP) of Paraguay in 2007 to that in 2011?
Provide a succinct answer. 0.47. What is the ratio of the Claims (% of GDP) of Philippines in 2007 to that in 2011?
Offer a terse response. 0.92. What is the ratio of the Claims (% of GDP) in Uganda in 2007 to that in 2011?
Your answer should be very brief. 0.69. What is the ratio of the Claims (% of GDP) in Paraguay in 2007 to that in 2012?
Ensure brevity in your answer.  0.44. What is the ratio of the Claims (% of GDP) of Philippines in 2007 to that in 2012?
Make the answer very short. 0.88. What is the ratio of the Claims (% of GDP) in Uganda in 2007 to that in 2012?
Keep it short and to the point. 0.78. What is the ratio of the Claims (% of GDP) in Antigua and Barbuda in 2007 to that in 2013?
Your answer should be very brief. 0.95. What is the ratio of the Claims (% of GDP) in Paraguay in 2007 to that in 2013?
Make the answer very short. 0.41. What is the ratio of the Claims (% of GDP) of Philippines in 2007 to that in 2013?
Offer a very short reply. 0.84. What is the ratio of the Claims (% of GDP) in Uganda in 2007 to that in 2013?
Provide a succinct answer. 0.79. What is the ratio of the Claims (% of GDP) in Antigua and Barbuda in 2008 to that in 2009?
Provide a succinct answer. 0.88. What is the ratio of the Claims (% of GDP) in Paraguay in 2008 to that in 2009?
Ensure brevity in your answer.  0.83. What is the ratio of the Claims (% of GDP) in Philippines in 2008 to that in 2009?
Offer a terse response. 0.98. What is the ratio of the Claims (% of GDP) of Uganda in 2008 to that in 2009?
Your answer should be compact. 1.2. What is the ratio of the Claims (% of GDP) of Antigua and Barbuda in 2008 to that in 2010?
Provide a short and direct response. 0.83. What is the ratio of the Claims (% of GDP) in Paraguay in 2008 to that in 2010?
Offer a terse response. 0.73. What is the ratio of the Claims (% of GDP) of Philippines in 2008 to that in 2010?
Offer a very short reply. 0.98. What is the ratio of the Claims (% of GDP) of Uganda in 2008 to that in 2010?
Ensure brevity in your answer.  1.06. What is the ratio of the Claims (% of GDP) in Antigua and Barbuda in 2008 to that in 2011?
Your answer should be compact. 0.86. What is the ratio of the Claims (% of GDP) in Paraguay in 2008 to that in 2011?
Your answer should be compact. 0.65. What is the ratio of the Claims (% of GDP) of Philippines in 2008 to that in 2011?
Provide a short and direct response. 0.9. What is the ratio of the Claims (% of GDP) of Uganda in 2008 to that in 2011?
Provide a short and direct response. 0.92. What is the ratio of the Claims (% of GDP) in Antigua and Barbuda in 2008 to that in 2012?
Offer a very short reply. 0.94. What is the ratio of the Claims (% of GDP) in Paraguay in 2008 to that in 2012?
Provide a succinct answer. 0.6. What is the ratio of the Claims (% of GDP) of Philippines in 2008 to that in 2012?
Your answer should be very brief. 0.86. What is the ratio of the Claims (% of GDP) of Uganda in 2008 to that in 2012?
Your answer should be compact. 1.04. What is the ratio of the Claims (% of GDP) of Antigua and Barbuda in 2008 to that in 2013?
Your answer should be very brief. 0.96. What is the ratio of the Claims (% of GDP) of Paraguay in 2008 to that in 2013?
Provide a short and direct response. 0.56. What is the ratio of the Claims (% of GDP) in Philippines in 2008 to that in 2013?
Give a very brief answer. 0.82. What is the ratio of the Claims (% of GDP) of Uganda in 2008 to that in 2013?
Offer a very short reply. 1.05. What is the ratio of the Claims (% of GDP) of Antigua and Barbuda in 2009 to that in 2010?
Your answer should be compact. 0.94. What is the ratio of the Claims (% of GDP) of Paraguay in 2009 to that in 2010?
Your answer should be compact. 0.88. What is the ratio of the Claims (% of GDP) of Philippines in 2009 to that in 2010?
Ensure brevity in your answer.  0.99. What is the ratio of the Claims (% of GDP) in Uganda in 2009 to that in 2010?
Give a very brief answer. 0.88. What is the ratio of the Claims (% of GDP) in Antigua and Barbuda in 2009 to that in 2011?
Your answer should be compact. 0.97. What is the ratio of the Claims (% of GDP) of Paraguay in 2009 to that in 2011?
Provide a succinct answer. 0.79. What is the ratio of the Claims (% of GDP) of Philippines in 2009 to that in 2011?
Keep it short and to the point. 0.91. What is the ratio of the Claims (% of GDP) in Uganda in 2009 to that in 2011?
Your answer should be very brief. 0.76. What is the ratio of the Claims (% of GDP) in Antigua and Barbuda in 2009 to that in 2012?
Your response must be concise. 1.07. What is the ratio of the Claims (% of GDP) in Paraguay in 2009 to that in 2012?
Offer a terse response. 0.73. What is the ratio of the Claims (% of GDP) in Philippines in 2009 to that in 2012?
Make the answer very short. 0.87. What is the ratio of the Claims (% of GDP) of Uganda in 2009 to that in 2012?
Make the answer very short. 0.87. What is the ratio of the Claims (% of GDP) in Antigua and Barbuda in 2009 to that in 2013?
Provide a short and direct response. 1.09. What is the ratio of the Claims (% of GDP) of Paraguay in 2009 to that in 2013?
Your answer should be very brief. 0.68. What is the ratio of the Claims (% of GDP) in Philippines in 2009 to that in 2013?
Make the answer very short. 0.84. What is the ratio of the Claims (% of GDP) in Uganda in 2009 to that in 2013?
Offer a terse response. 0.88. What is the ratio of the Claims (% of GDP) of Antigua and Barbuda in 2010 to that in 2011?
Ensure brevity in your answer.  1.04. What is the ratio of the Claims (% of GDP) in Paraguay in 2010 to that in 2011?
Provide a succinct answer. 0.89. What is the ratio of the Claims (% of GDP) in Philippines in 2010 to that in 2011?
Keep it short and to the point. 0.92. What is the ratio of the Claims (% of GDP) in Uganda in 2010 to that in 2011?
Provide a short and direct response. 0.87. What is the ratio of the Claims (% of GDP) in Antigua and Barbuda in 2010 to that in 2012?
Provide a short and direct response. 1.14. What is the ratio of the Claims (% of GDP) of Paraguay in 2010 to that in 2012?
Provide a short and direct response. 0.82. What is the ratio of the Claims (% of GDP) of Philippines in 2010 to that in 2012?
Provide a short and direct response. 0.88. What is the ratio of the Claims (% of GDP) in Uganda in 2010 to that in 2012?
Make the answer very short. 0.98. What is the ratio of the Claims (% of GDP) of Antigua and Barbuda in 2010 to that in 2013?
Your response must be concise. 1.16. What is the ratio of the Claims (% of GDP) of Paraguay in 2010 to that in 2013?
Ensure brevity in your answer.  0.77. What is the ratio of the Claims (% of GDP) in Philippines in 2010 to that in 2013?
Offer a very short reply. 0.84. What is the ratio of the Claims (% of GDP) of Uganda in 2010 to that in 2013?
Offer a very short reply. 0.99. What is the ratio of the Claims (% of GDP) in Antigua and Barbuda in 2011 to that in 2012?
Ensure brevity in your answer.  1.1. What is the ratio of the Claims (% of GDP) in Paraguay in 2011 to that in 2012?
Your response must be concise. 0.92. What is the ratio of the Claims (% of GDP) in Philippines in 2011 to that in 2012?
Ensure brevity in your answer.  0.96. What is the ratio of the Claims (% of GDP) of Uganda in 2011 to that in 2012?
Ensure brevity in your answer.  1.13. What is the ratio of the Claims (% of GDP) of Antigua and Barbuda in 2011 to that in 2013?
Your answer should be compact. 1.12. What is the ratio of the Claims (% of GDP) of Paraguay in 2011 to that in 2013?
Keep it short and to the point. 0.86. What is the ratio of the Claims (% of GDP) of Philippines in 2011 to that in 2013?
Offer a very short reply. 0.92. What is the ratio of the Claims (% of GDP) of Uganda in 2011 to that in 2013?
Your answer should be very brief. 1.15. What is the ratio of the Claims (% of GDP) in Antigua and Barbuda in 2012 to that in 2013?
Keep it short and to the point. 1.02. What is the ratio of the Claims (% of GDP) of Paraguay in 2012 to that in 2013?
Give a very brief answer. 0.93. What is the ratio of the Claims (% of GDP) of Philippines in 2012 to that in 2013?
Provide a short and direct response. 0.96. What is the ratio of the Claims (% of GDP) in Uganda in 2012 to that in 2013?
Your answer should be compact. 1.01. What is the difference between the highest and the second highest Claims (% of GDP) in Antigua and Barbuda?
Make the answer very short. 2.99. What is the difference between the highest and the second highest Claims (% of GDP) in Paraguay?
Your answer should be compact. 3.06. What is the difference between the highest and the second highest Claims (% of GDP) in Philippines?
Make the answer very short. 1.77. What is the difference between the highest and the second highest Claims (% of GDP) in Uganda?
Provide a succinct answer. 1.23. What is the difference between the highest and the lowest Claims (% of GDP) of Antigua and Barbuda?
Provide a short and direct response. 15.47. What is the difference between the highest and the lowest Claims (% of GDP) in Paraguay?
Make the answer very short. 27.36. What is the difference between the highest and the lowest Claims (% of GDP) in Philippines?
Your answer should be compact. 7.83. What is the difference between the highest and the lowest Claims (% of GDP) in Uganda?
Keep it short and to the point. 4.88. 